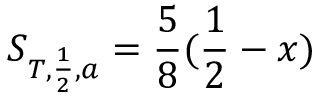<formula> <loc_0><loc_0><loc_500><loc_500>S _ { T , \frac { 1 } { 2 } , a } = \frac { 5 } { 8 } ( \frac { 1 } { 2 } - x )</formula> 